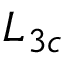Convert formula to latex. <formula><loc_0><loc_0><loc_500><loc_500>L _ { 3 c }</formula> 